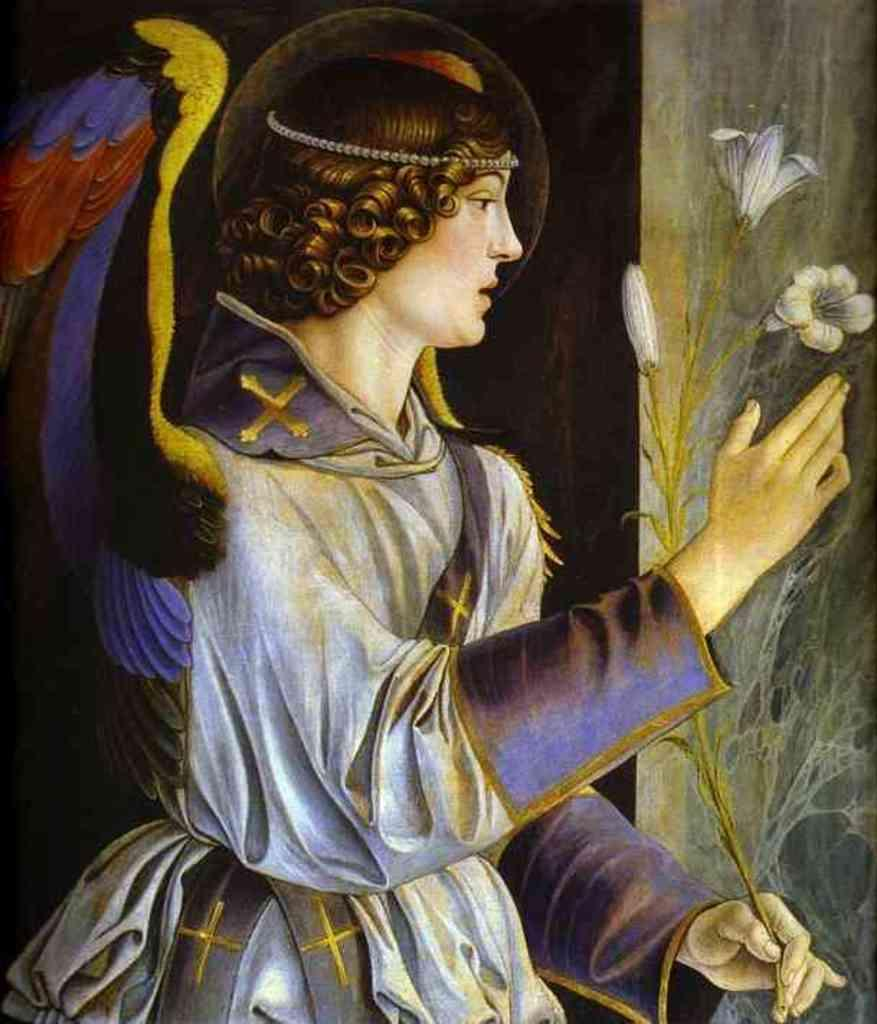What is the main subject of the painting in the image? The painting contains a person. What other elements are present in the painting? The painting contains flowers. How many ladybugs can be seen on the person in the painting? There are no ladybugs visible on the person in the painting. What type of beef is being cooked in the background of the painting? There is no beef present in the painting; it only contains a person and flowers. 